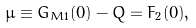Convert formula to latex. <formula><loc_0><loc_0><loc_500><loc_500>\mu \equiv G _ { M 1 } ( 0 ) - Q = F _ { 2 } ( 0 ) ,</formula> 